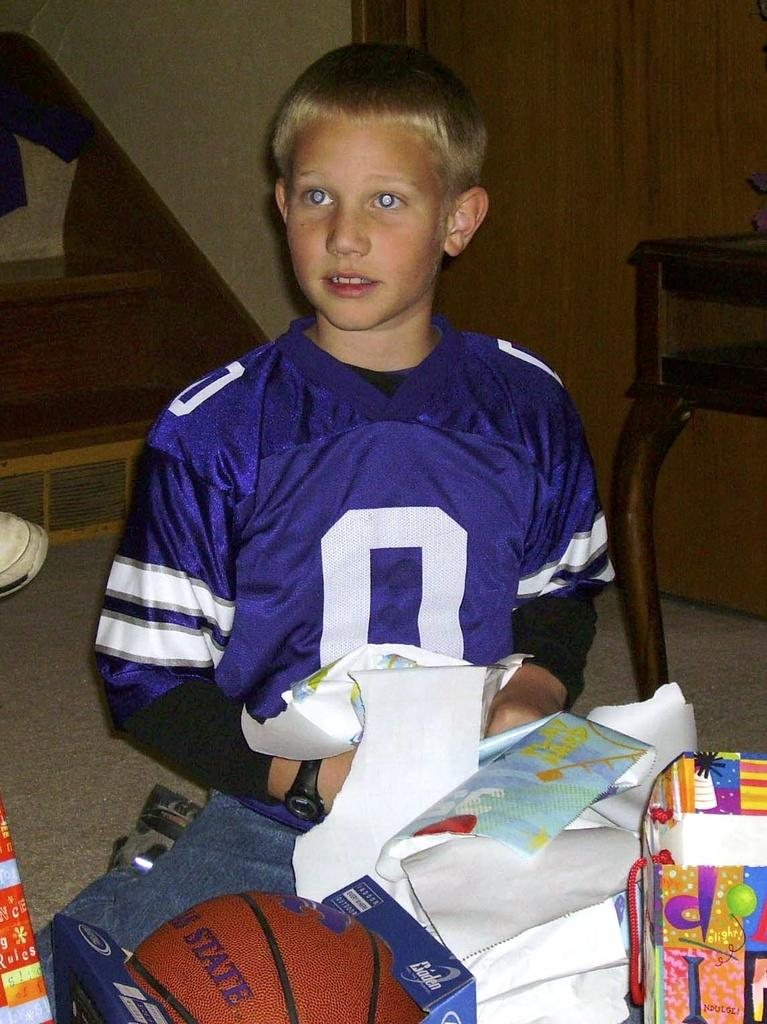<image>
Summarize the visual content of the image. A boy wearing a sports jersey with the number 0 on it, opens presents. 